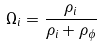Convert formula to latex. <formula><loc_0><loc_0><loc_500><loc_500>\Omega _ { i } = \frac { \rho _ { i } } { \rho _ { i } + \rho _ { \phi } }</formula> 